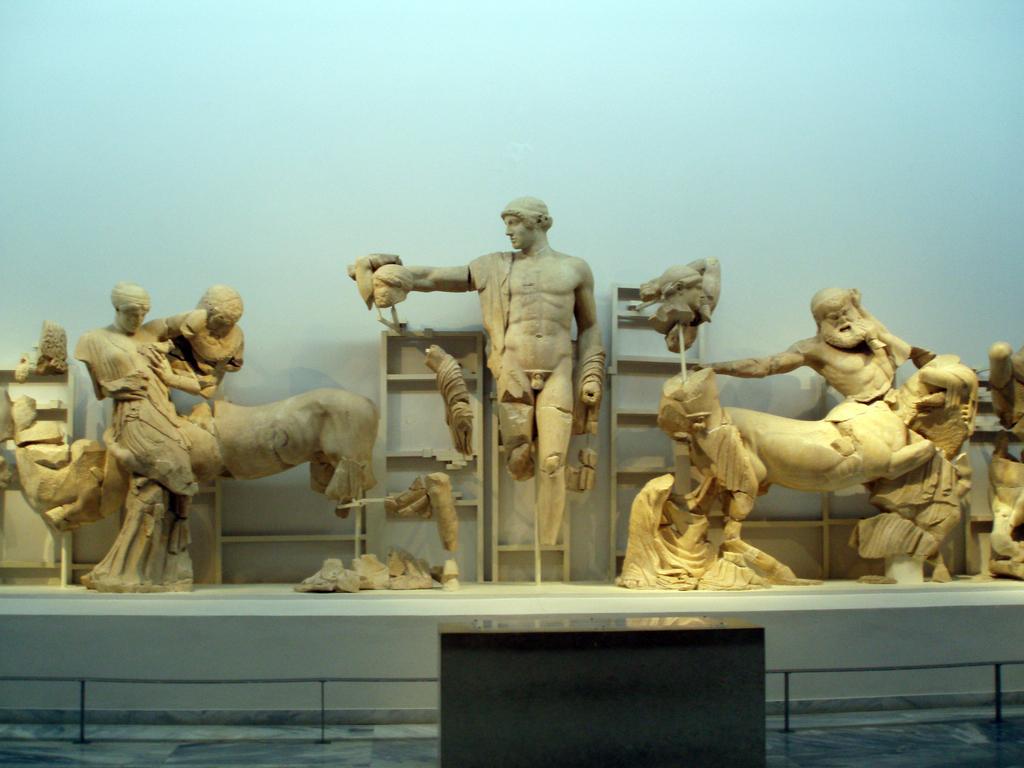Describe this image in one or two sentences. In this image I can see few statues in cream color and they are on the white color surface. Background is in blue and white color. 